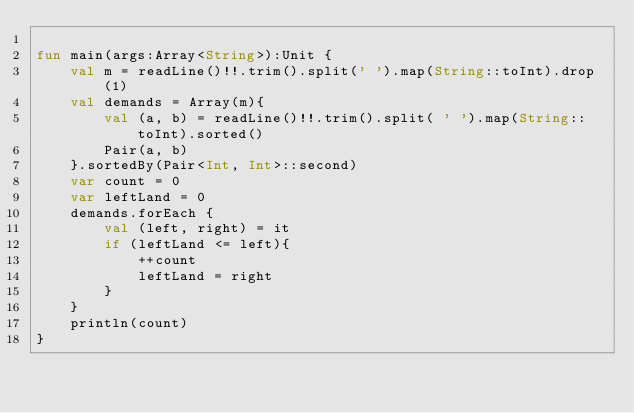Convert code to text. <code><loc_0><loc_0><loc_500><loc_500><_Kotlin_>
fun main(args:Array<String>):Unit {
    val m = readLine()!!.trim().split(' ').map(String::toInt).drop(1)
    val demands = Array(m){
        val (a, b) = readLine()!!.trim().split( ' ').map(String::toInt).sorted()
        Pair(a, b)
    }.sortedBy(Pair<Int, Int>::second)
    var count = 0
    var leftLand = 0
    demands.forEach {
        val (left, right) = it
        if (leftLand <= left){
            ++count
            leftLand = right
        }
    }
    println(count)
}</code> 